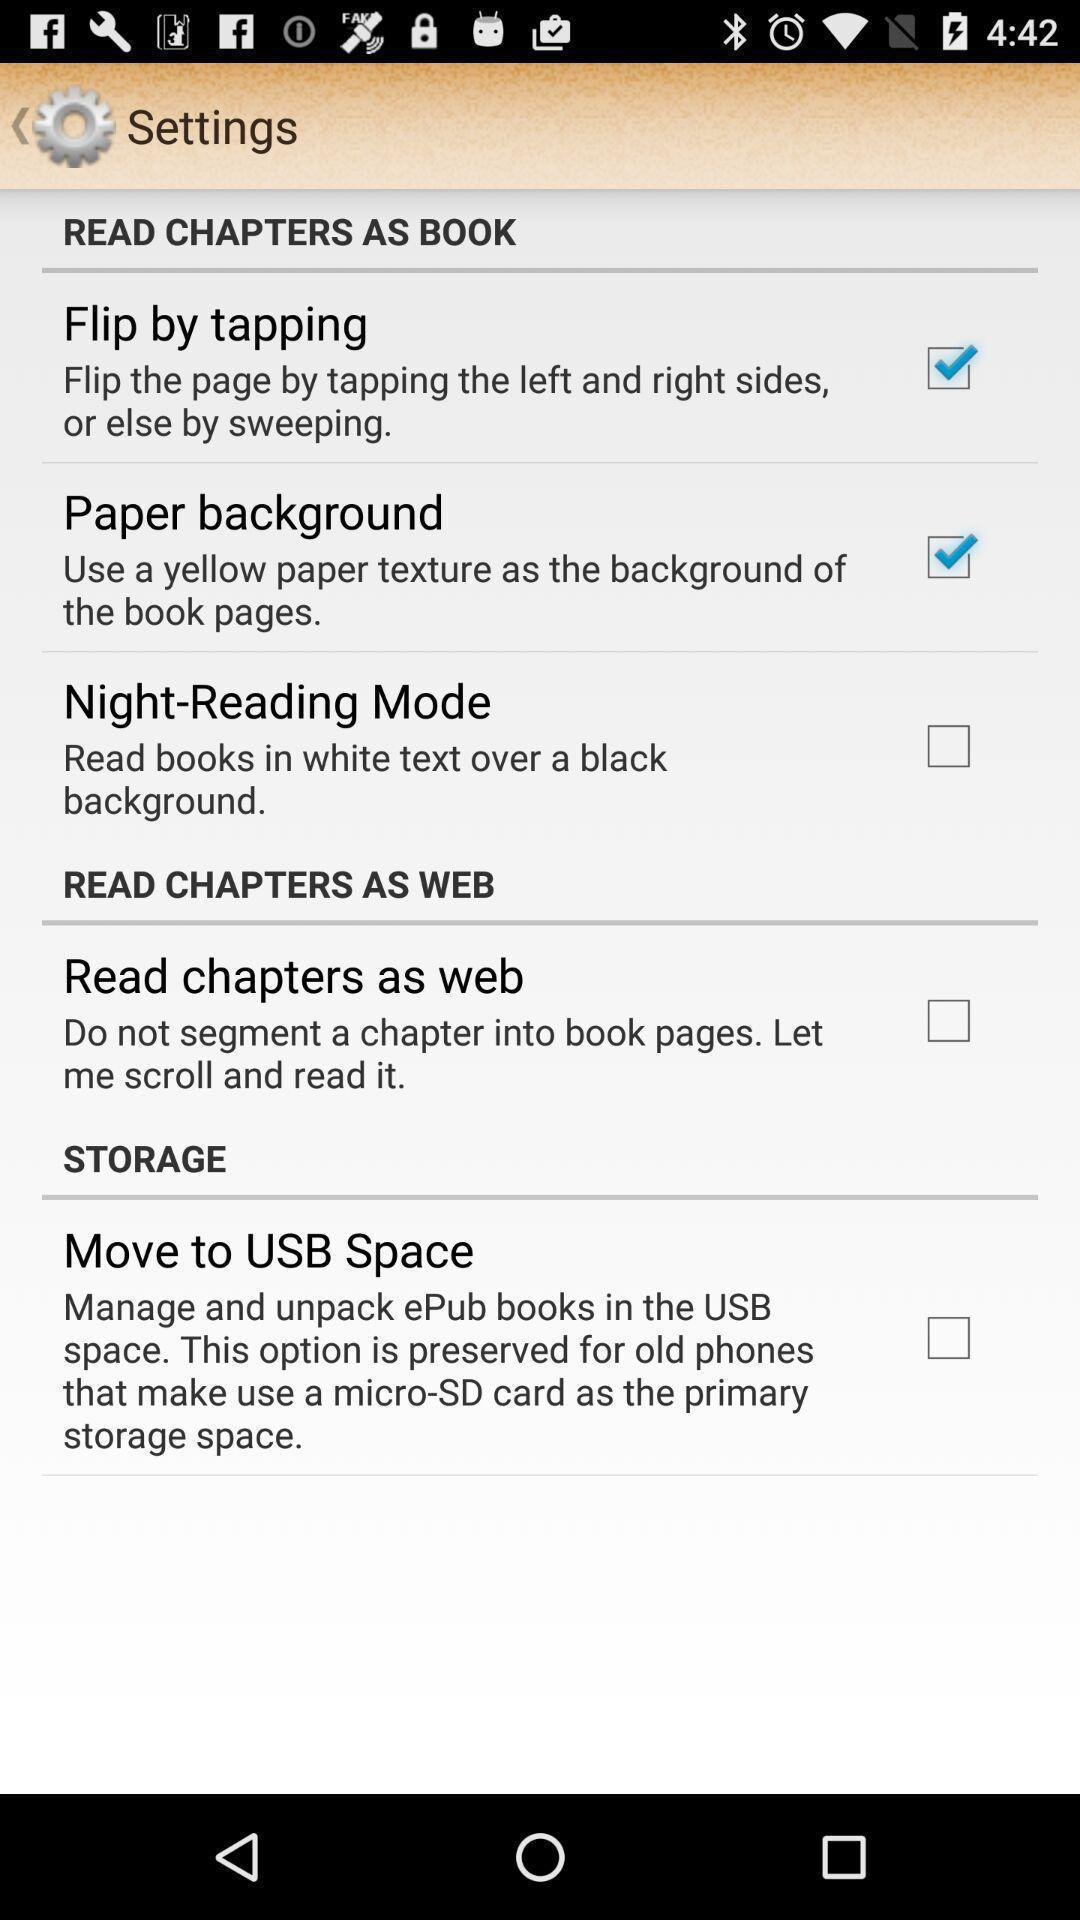Summarize the information in this screenshot. Settings page of a learning app. 